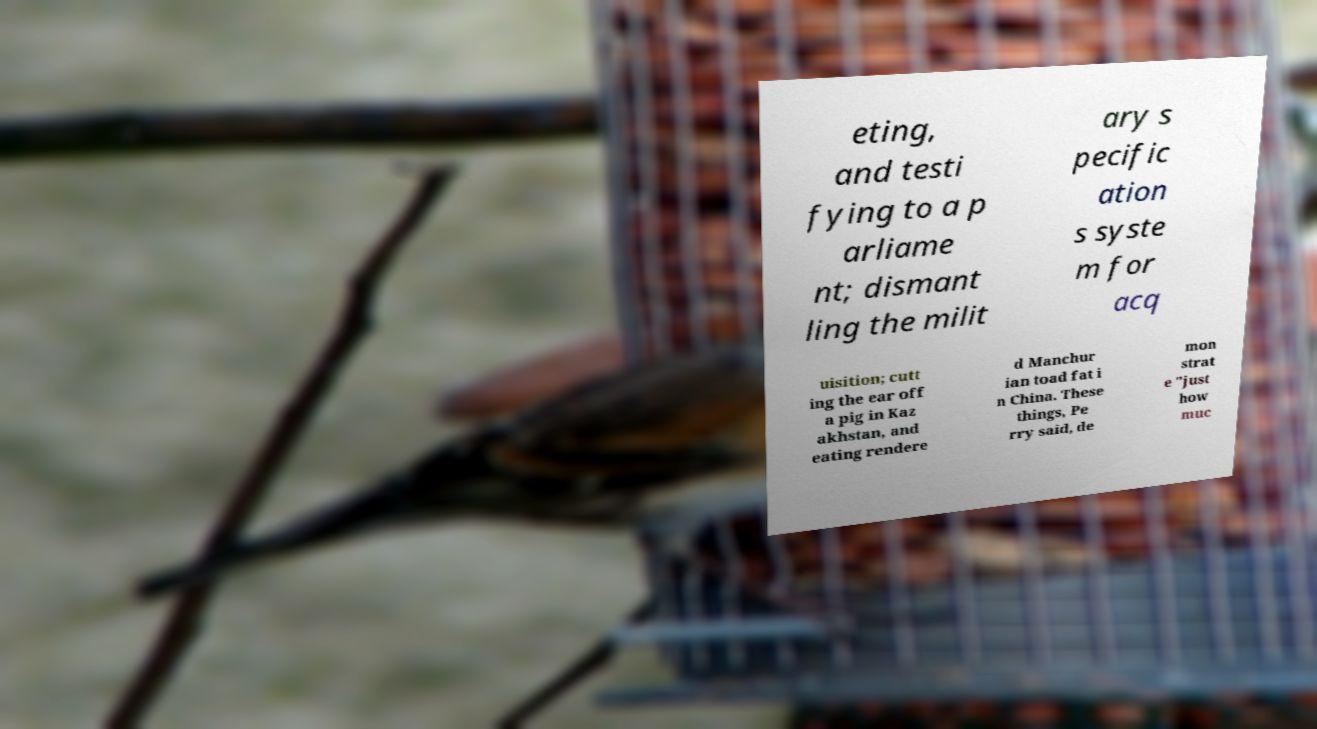Please identify and transcribe the text found in this image. eting, and testi fying to a p arliame nt; dismant ling the milit ary s pecific ation s syste m for acq uisition; cutt ing the ear off a pig in Kaz akhstan, and eating rendere d Manchur ian toad fat i n China. These things, Pe rry said, de mon strat e "just how muc 